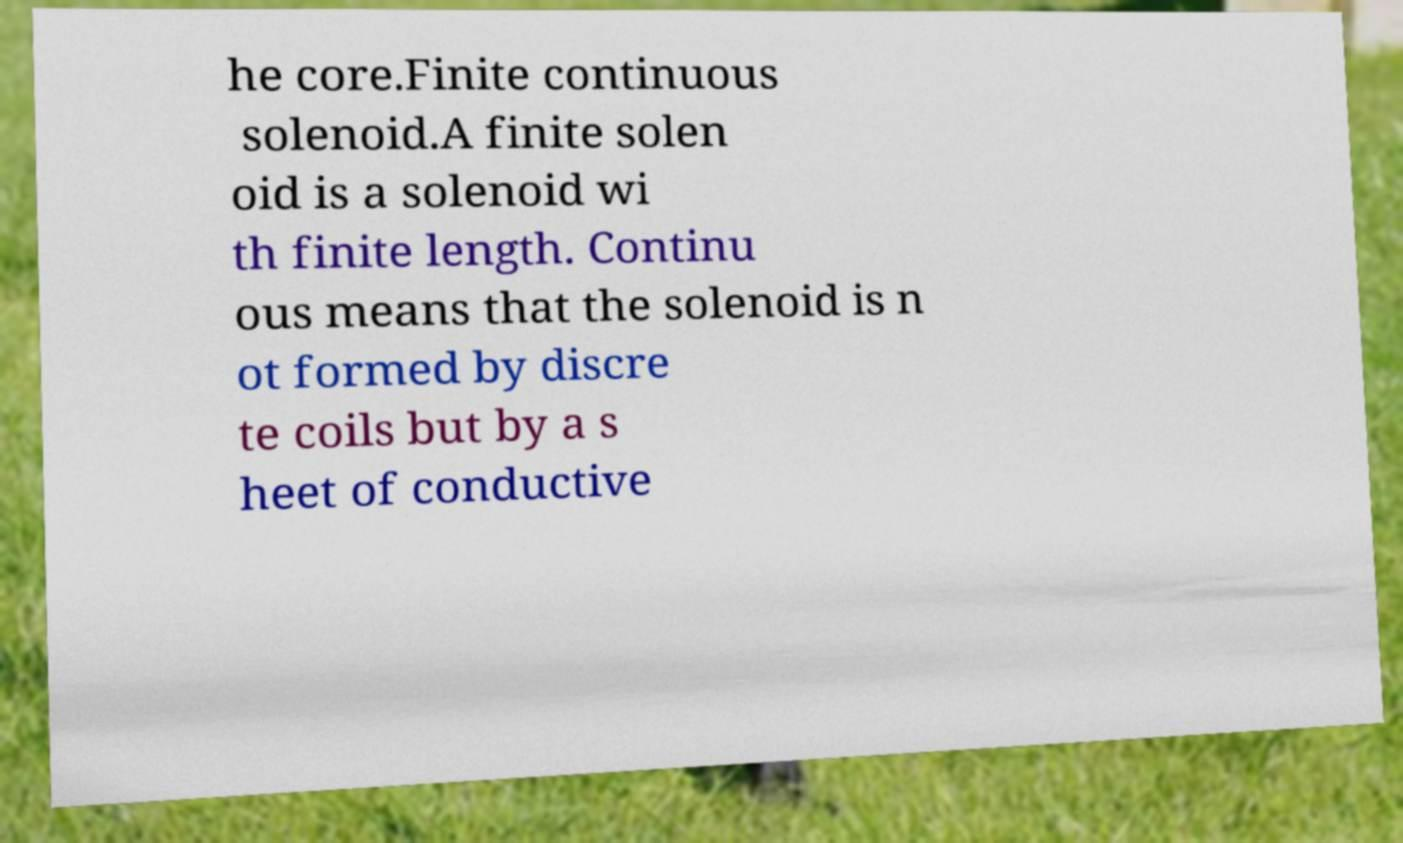There's text embedded in this image that I need extracted. Can you transcribe it verbatim? he core.Finite continuous solenoid.A finite solen oid is a solenoid wi th finite length. Continu ous means that the solenoid is n ot formed by discre te coils but by a s heet of conductive 